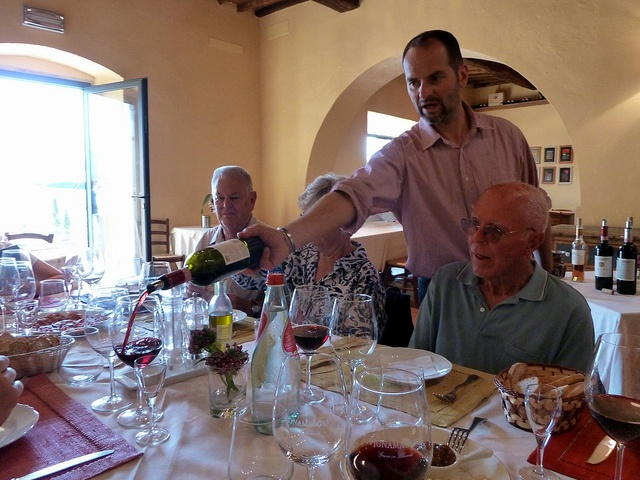Describe the objects in this image and their specific colors. I can see dining table in gray and black tones, people in gray, maroon, brown, and black tones, people in gray, black, maroon, and brown tones, wine glass in gray and black tones, and wine glass in gray, black, maroon, and lightblue tones in this image. 